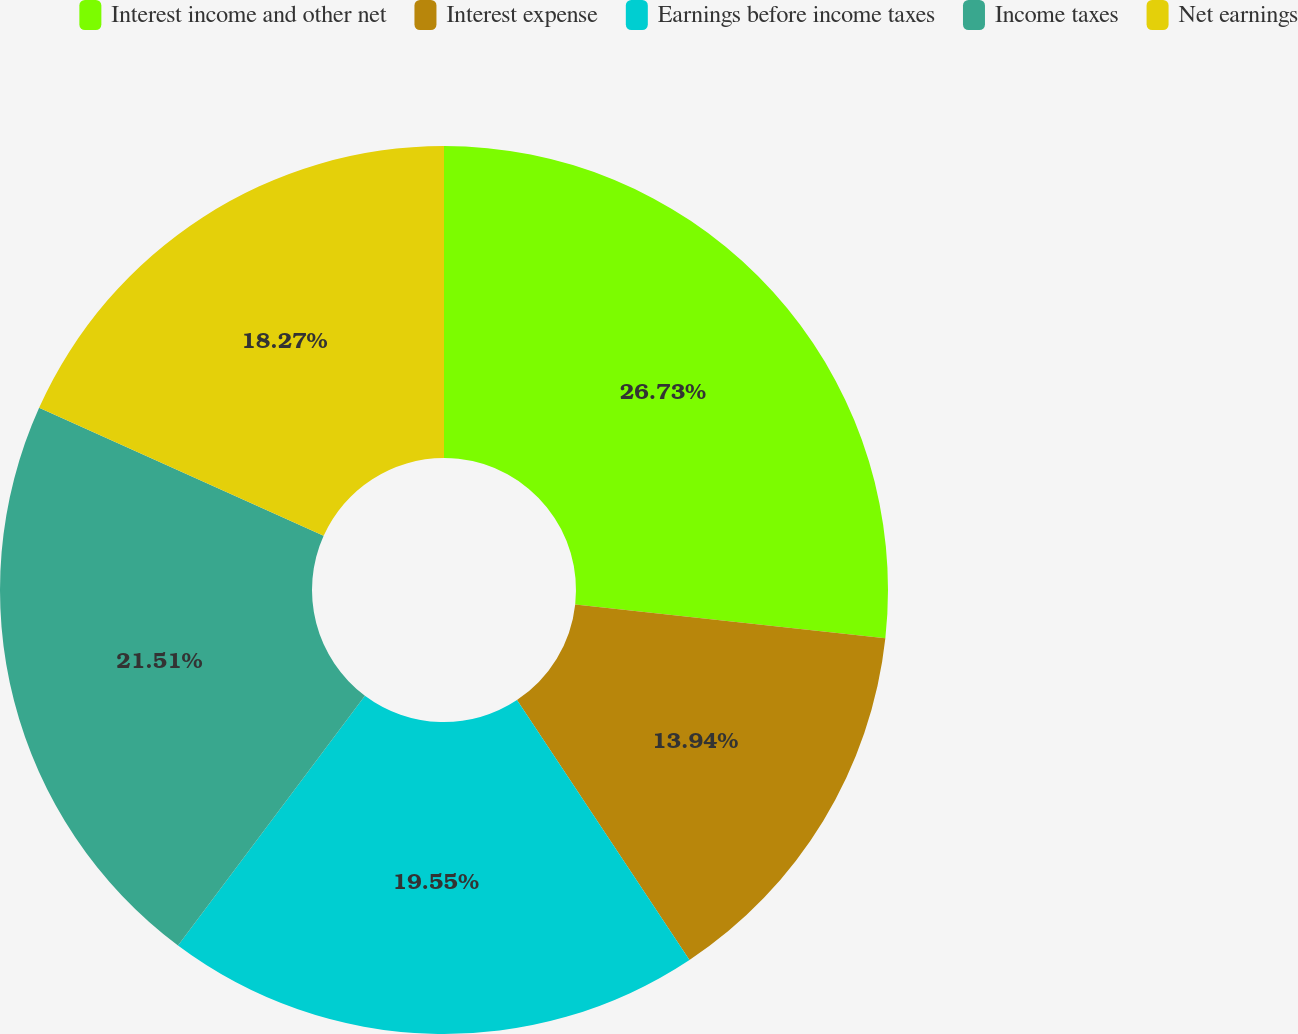<chart> <loc_0><loc_0><loc_500><loc_500><pie_chart><fcel>Interest income and other net<fcel>Interest expense<fcel>Earnings before income taxes<fcel>Income taxes<fcel>Net earnings<nl><fcel>26.74%<fcel>13.94%<fcel>19.55%<fcel>21.51%<fcel>18.27%<nl></chart> 